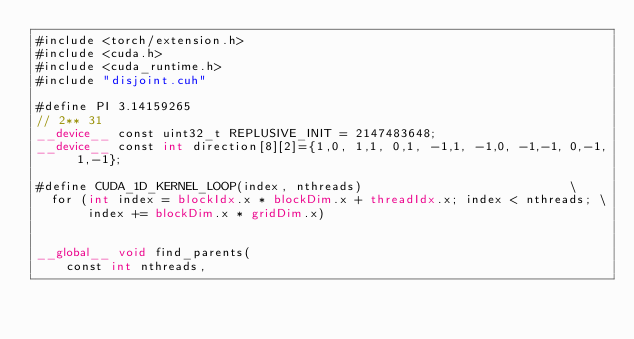Convert code to text. <code><loc_0><loc_0><loc_500><loc_500><_Cuda_>#include <torch/extension.h>
#include <cuda.h>
#include <cuda_runtime.h>
#include "disjoint.cuh"

#define PI 3.14159265
// 2** 31
__device__ const uint32_t REPLUSIVE_INIT = 2147483648;
__device__ const int direction[8][2]={1,0, 1,1, 0,1, -1,1, -1,0, -1,-1, 0,-1, 1,-1};

#define CUDA_1D_KERNEL_LOOP(index, nthreads)                            \
  for (int index = blockIdx.x * blockDim.x + threadIdx.x; index < nthreads; \
       index += blockDim.x * gridDim.x)


__global__ void find_parents(
    const int nthreads,</code> 